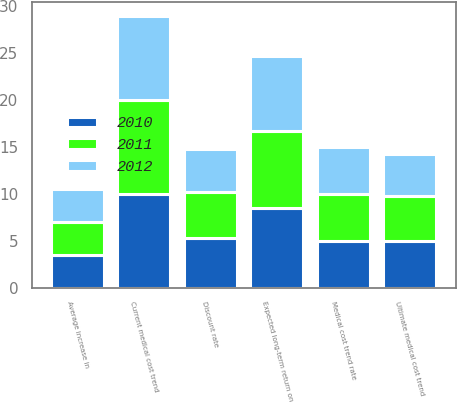Convert chart to OTSL. <chart><loc_0><loc_0><loc_500><loc_500><stacked_bar_chart><ecel><fcel>Discount rate<fcel>Average increase in<fcel>Expected long-term return on<fcel>Current medical cost trend<fcel>Ultimate medical cost trend<fcel>Medical cost trend rate<nl><fcel>2012<fcel>4.5<fcel>3.5<fcel>8<fcel>9<fcel>4.5<fcel>5<nl><fcel>2011<fcel>5<fcel>3.5<fcel>8.25<fcel>10<fcel>4.75<fcel>5<nl><fcel>2010<fcel>5.25<fcel>3.5<fcel>8.5<fcel>10<fcel>5<fcel>5<nl></chart> 